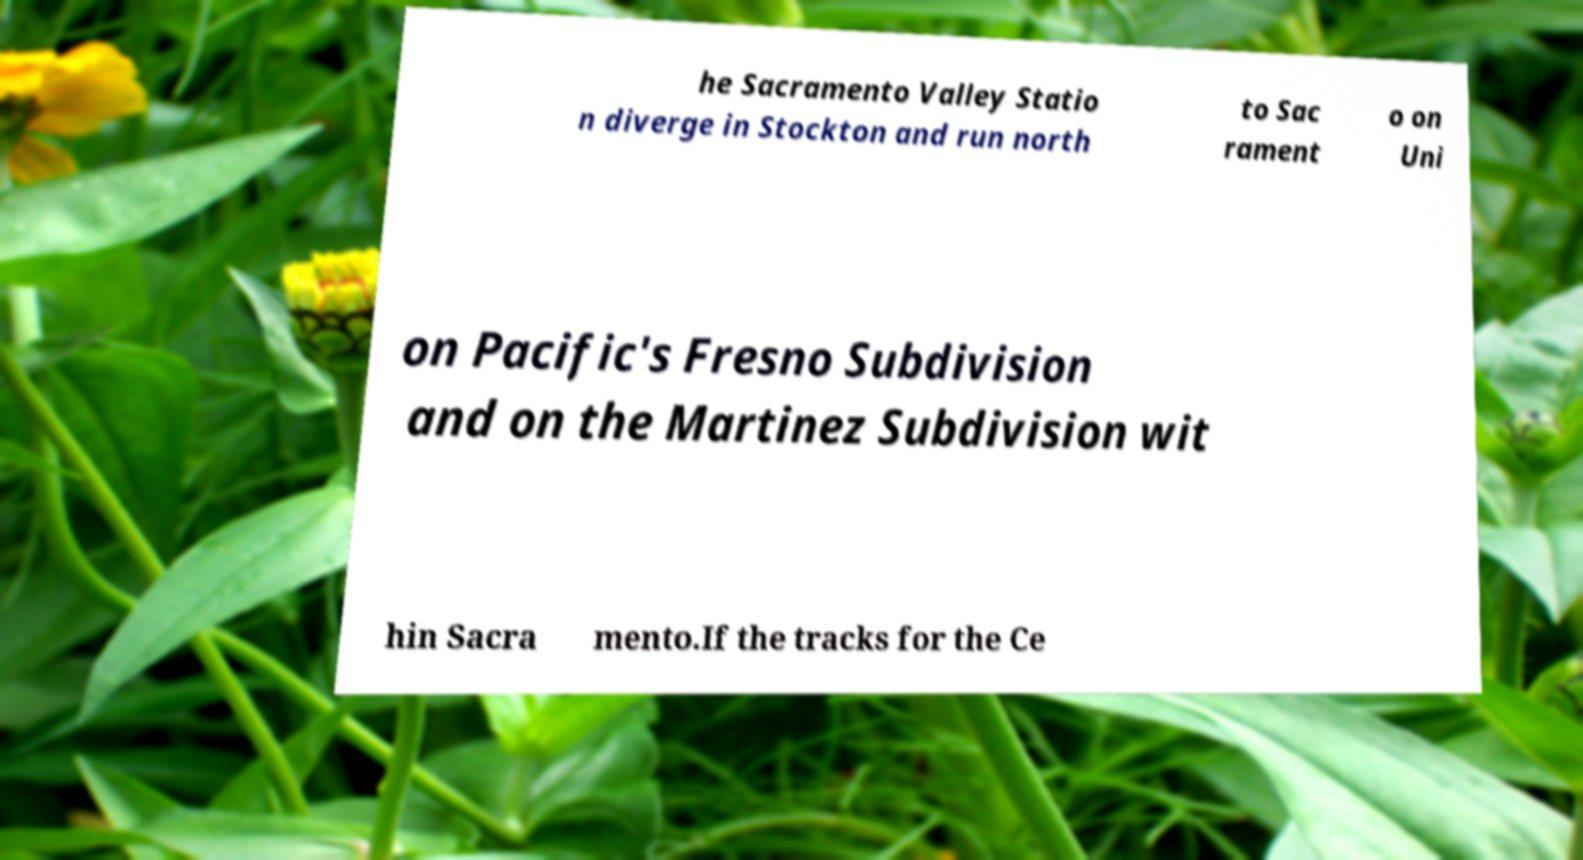For documentation purposes, I need the text within this image transcribed. Could you provide that? he Sacramento Valley Statio n diverge in Stockton and run north to Sac rament o on Uni on Pacific's Fresno Subdivision and on the Martinez Subdivision wit hin Sacra mento.If the tracks for the Ce 